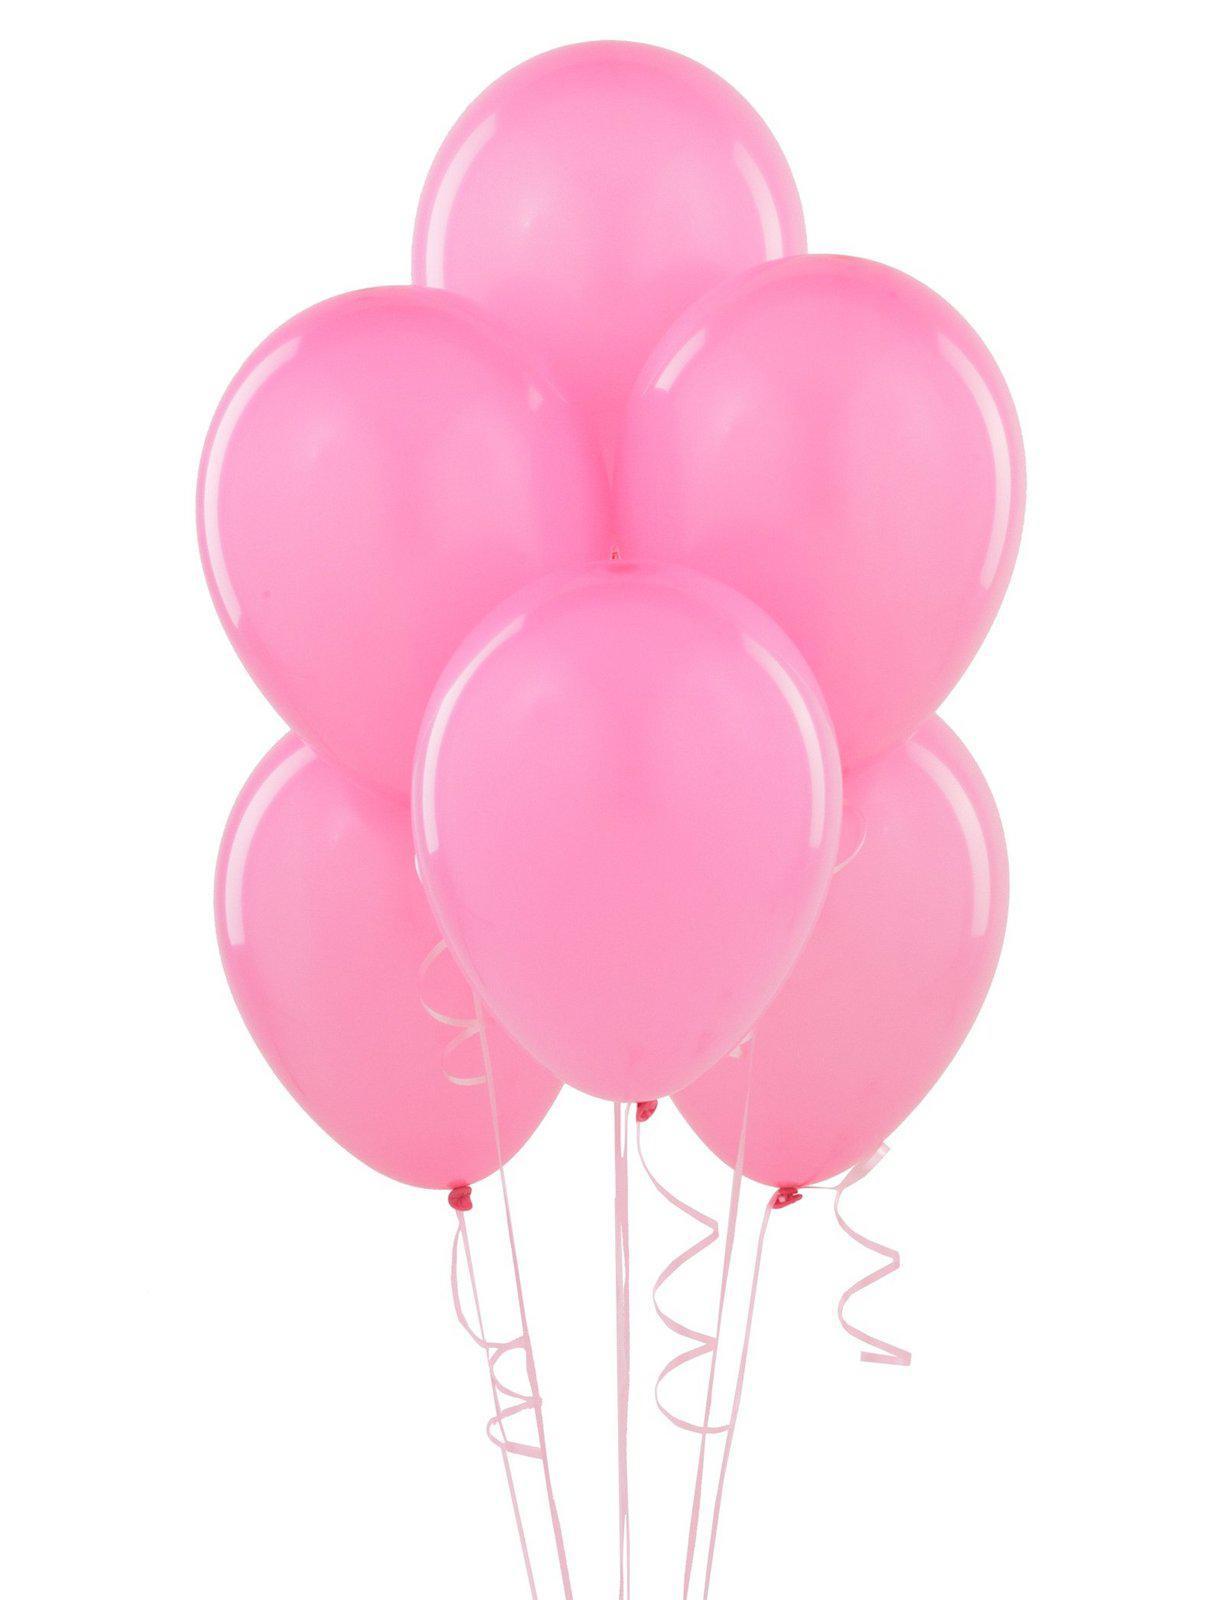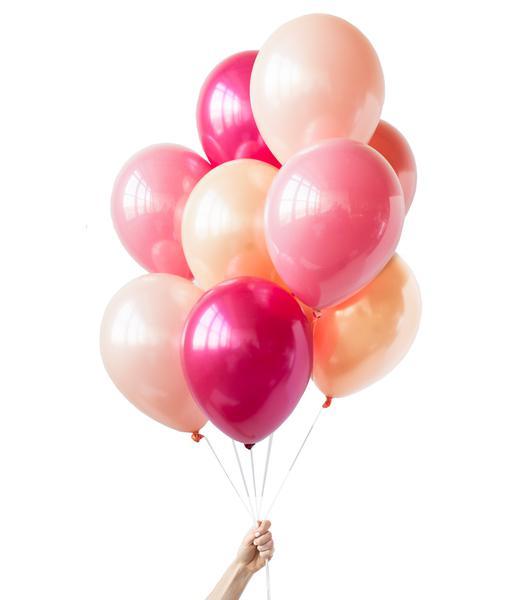The first image is the image on the left, the second image is the image on the right. For the images shown, is this caption "There are more balloons in the image on the left." true? Answer yes or no. No. The first image is the image on the left, the second image is the image on the right. Evaluate the accuracy of this statement regarding the images: "There are no less than 19 balloons.". Is it true? Answer yes or no. No. 